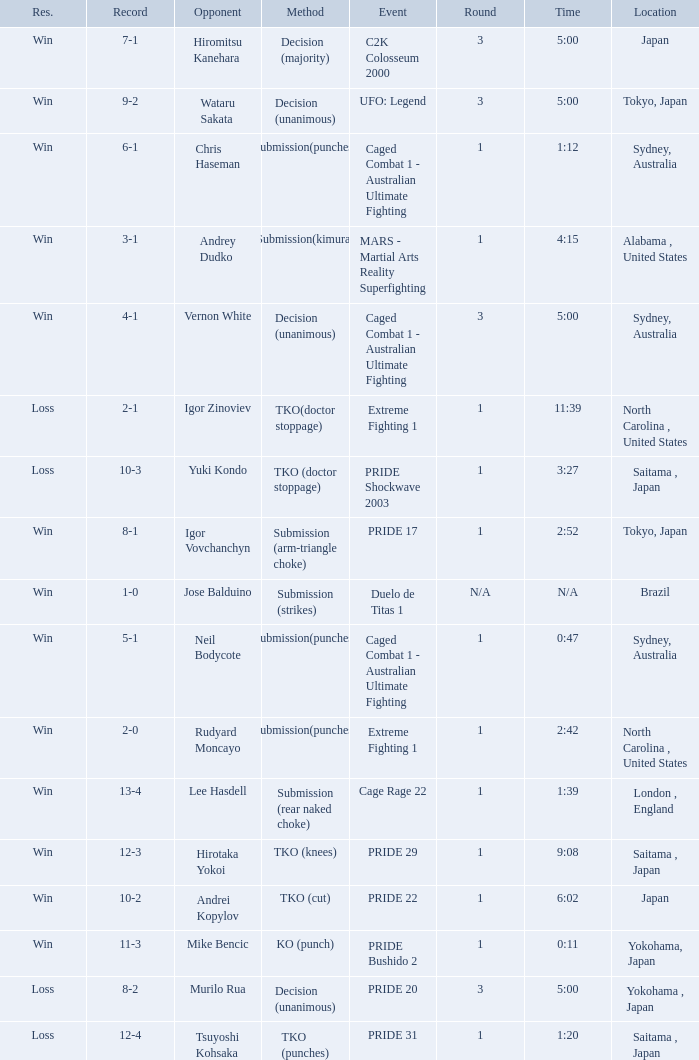Which Record has the Res of win with the Event of extreme fighting 1? 2-0. 